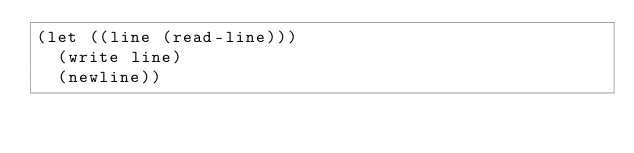Convert code to text. <code><loc_0><loc_0><loc_500><loc_500><_Scheme_>(let ((line (read-line)))
  (write line)
  (newline))
</code> 